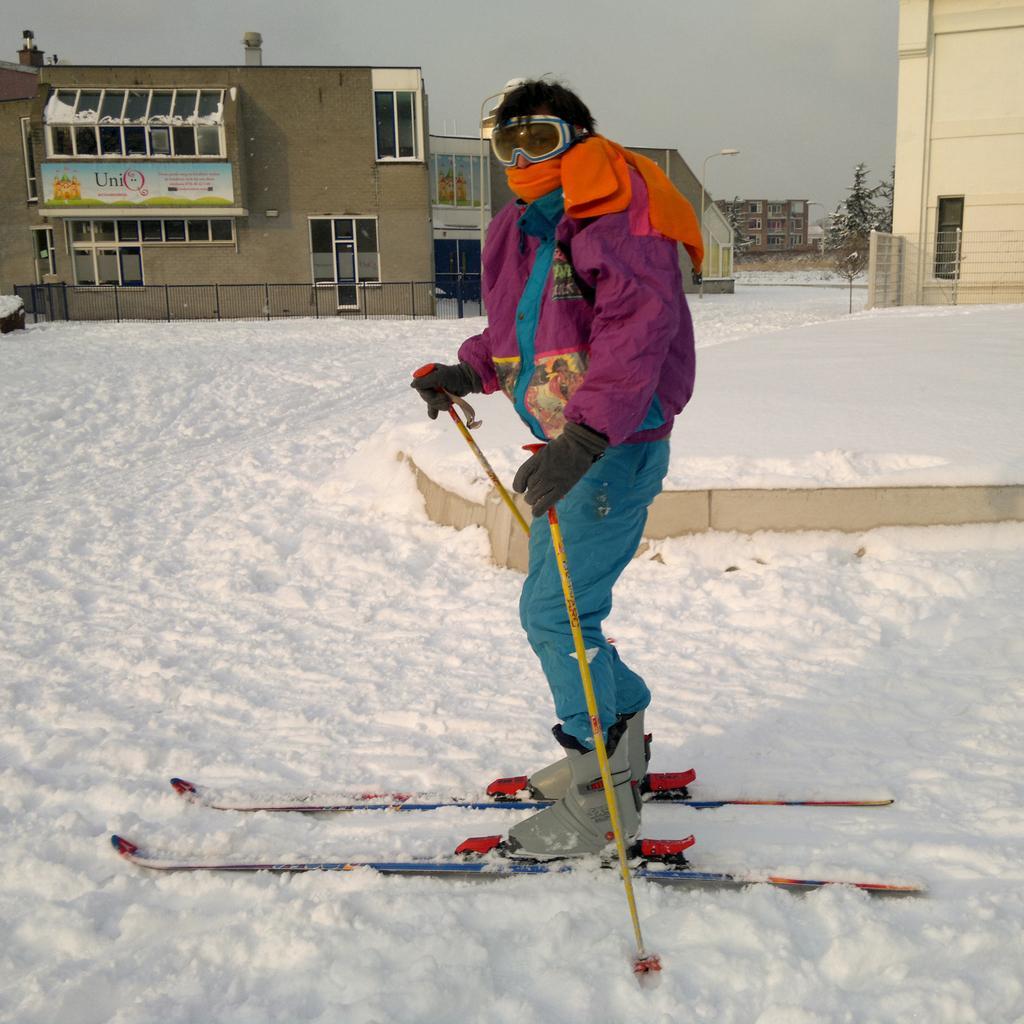Describe this image in one or two sentences. In the center of the image there is a man. He is wearing a ski board. In the background there is a building, tree and the sky. At the bottom there is a snow. 